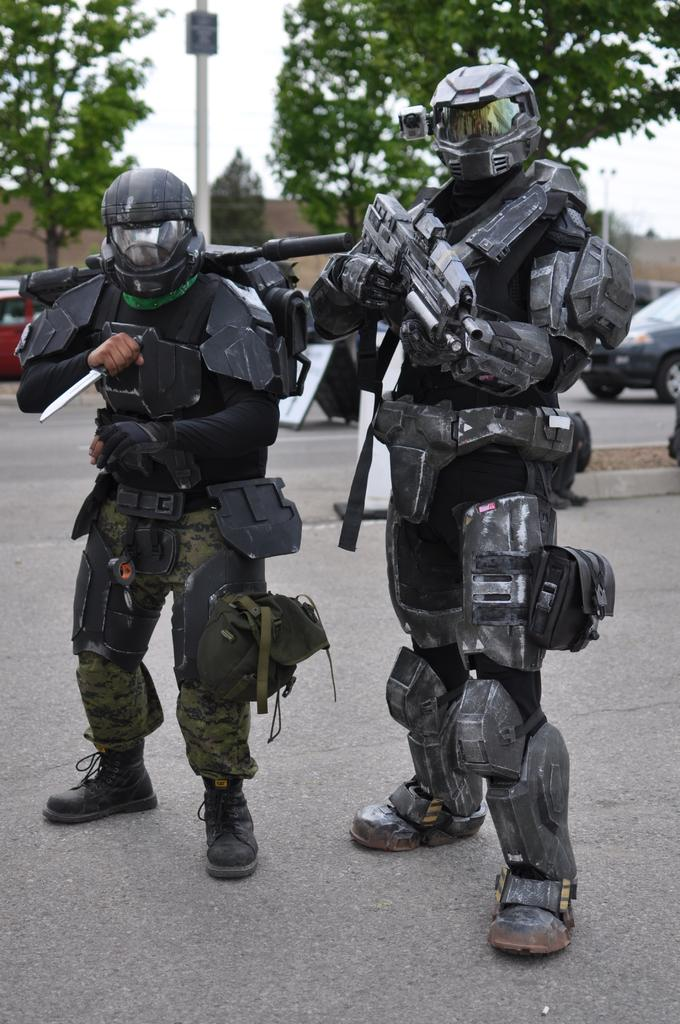How many people are in the image? There are two persons in the image. What are the persons wearing? The persons are wearing fancy dresses. What objects are being held by the persons? One person is holding a knife, and the other person is holding a rifle. What can be seen in the background of the image? There are vehicles, a pole, trees, buildings, and the sky visible in the background. What type of tax system is being discussed by the persons in the image? There is no indication in the image that the persons are discussing any tax system. 